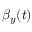<formula> <loc_0><loc_0><loc_500><loc_500>\beta _ { y } ( t )</formula> 